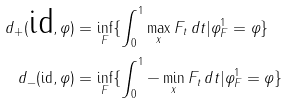Convert formula to latex. <formula><loc_0><loc_0><loc_500><loc_500>d _ { + } ( \text {id} , \varphi ) & = \inf _ { F } \{ \int _ { 0 } ^ { 1 } \max _ { x } F _ { t } \, d t | \varphi _ { F } ^ { 1 } = \varphi \} \\ d _ { - } ( \text {id} , \varphi ) & = \inf _ { F } \{ \int _ { 0 } ^ { 1 } - \min _ { x } F _ { t } \, d t | \varphi _ { F } ^ { 1 } = \varphi \}</formula> 